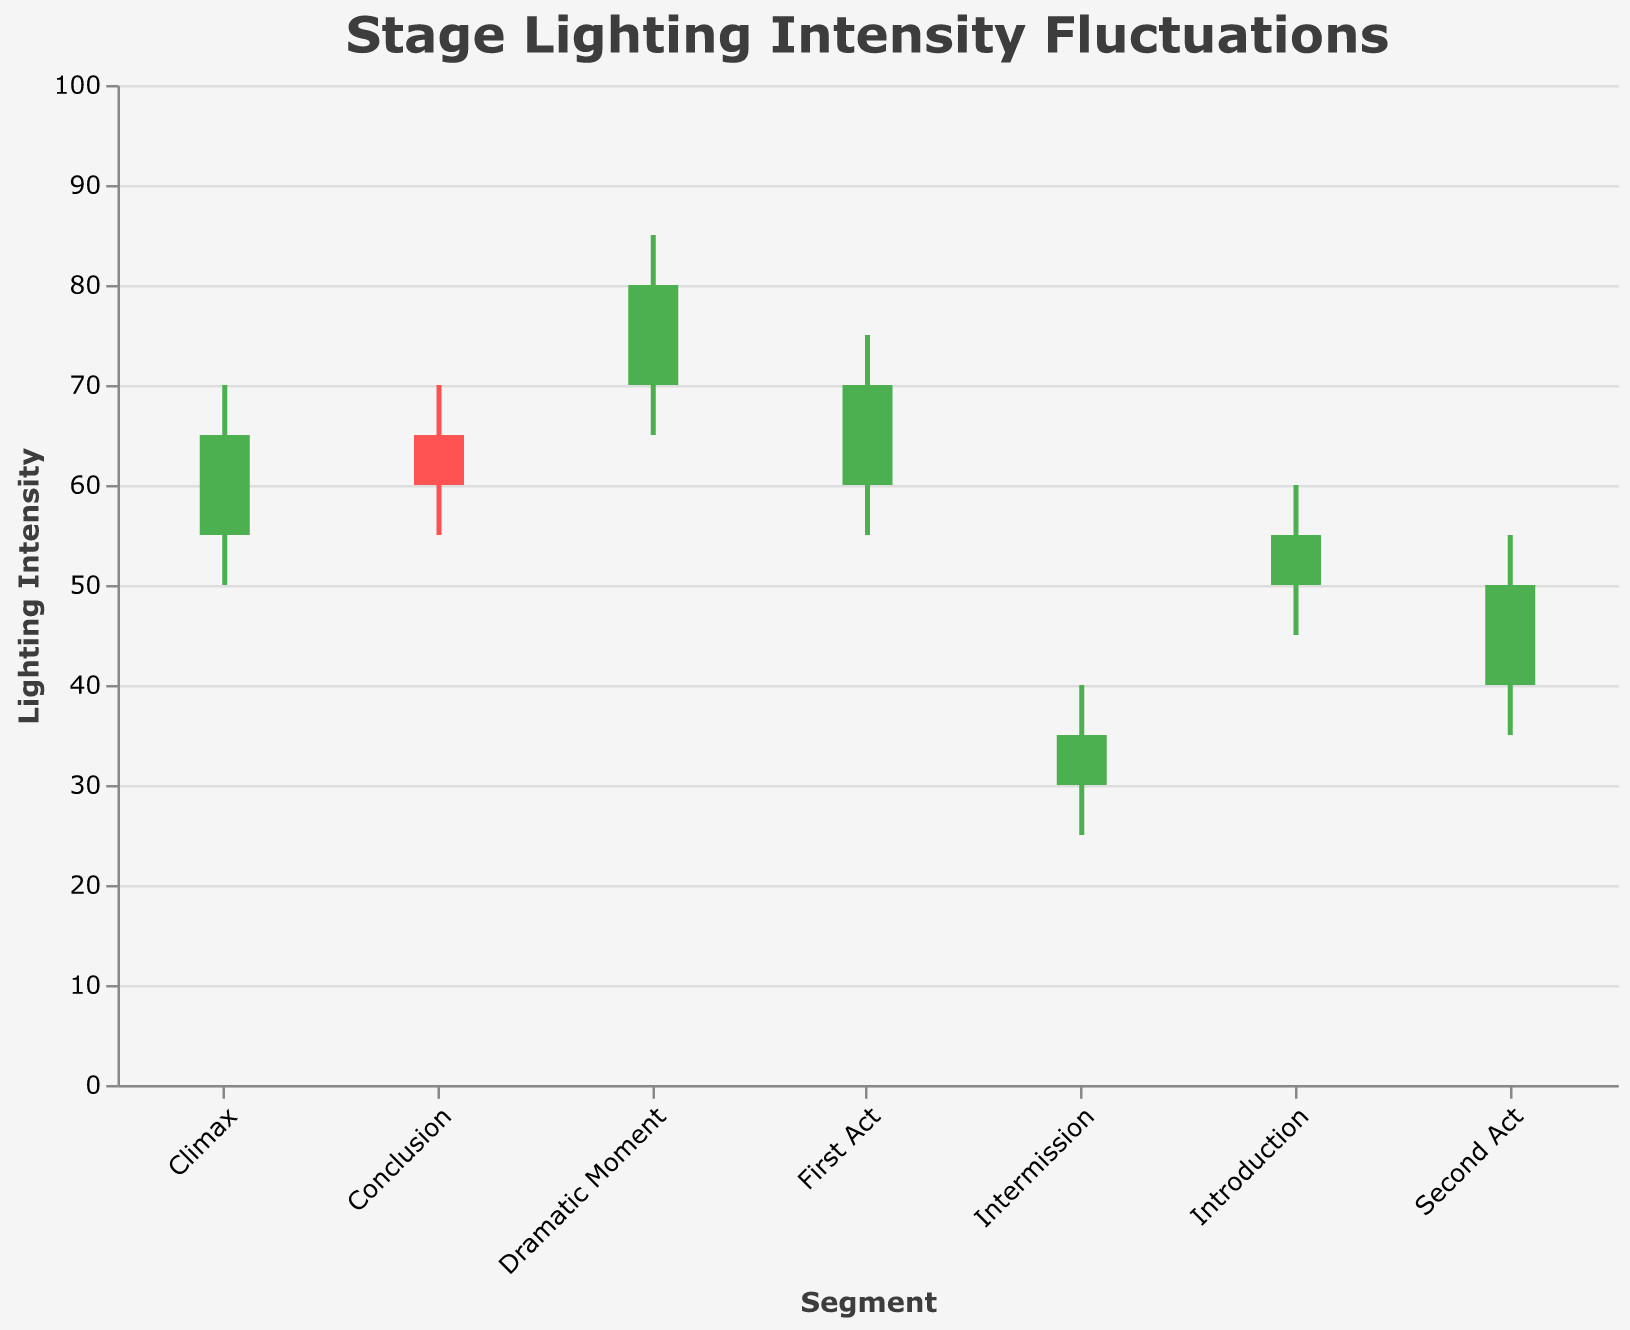What is the title of the figure? The title can be found at the top of the figure. It states the main topic represented by the plot, which is about stage lighting intensity fluctuations.
Answer: Stage Lighting Intensity Fluctuations Which segment shows the highest lighting intensity? To determine the highest lighting intensity, look for the segment with the highest "High" value. The "Dramatic Moment" segment has a high value of 85, the highest among all segments.
Answer: Dramatic Moment In which segment does the lighting intensity drop the most from high to low? Calculate the difference between the high and low values for each segment. The "Dramatic Moment" segment has a high of 85 and a low of 65, resulting in the largest drop of 20 (85-65=20).
Answer: Dramatic Moment Which segment has a closing intensity lower than the opening intensity? Identify the segments where the closing value is lower than the opening value. In the "Conclusion" segment, the opening intensity is 65 and the closing intensity is 60.
Answer: Conclusion What is the lighting intensity range during the Intermission? Range can be found by subtracting the low value from the high value for the "Intermission" segment. The high is 40 and the low is 25, so the range is 15 (40-25=15).
Answer: 15 How does the closing intensity in the Climax segment compare to the opening intensity in the Second Act? Compare the closing value of "Climax" (65) to the opening value of "Second Act" (40). The closing intensity in the Climax is greater than the opening intensity in the Second Act (65 > 40).
Answer: Climax is greater What is the average closing intensity across all segments? Sum all the closing values and divide by the number of segments: (55 + 70 + 80 + 35 + 50 + 65 + 60) / 7 = 415 / 7 = 59.29.
Answer: 59.29 Which segment saw the highest increase in lighting intensity from the opening to closing? Calculate the difference between the opening and closing values for each segment. The "Dramatic Moment" has an increase of 10 (80-70=10), which is the highest.
Answer: Dramatic Moment What is the median opening intensity value across all segments? Order the opening values: 30, 40, 50, 55, 60, 65, 70. The median is the middle value in the ordered list, which is 55.
Answer: 55 